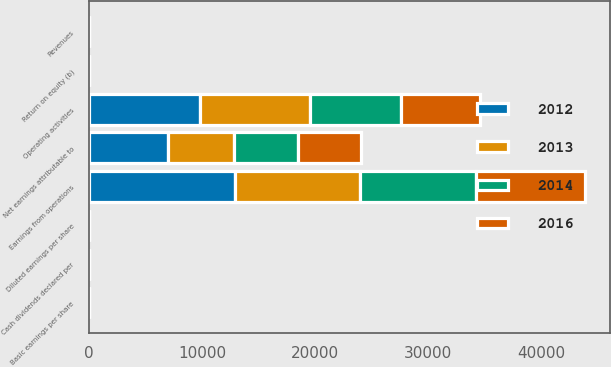<chart> <loc_0><loc_0><loc_500><loc_500><stacked_bar_chart><ecel><fcel>Revenues<fcel>Earnings from operations<fcel>Net earnings attributable to<fcel>Return on equity (b)<fcel>Basic earnings per share<fcel>Diluted earnings per share<fcel>Cash dividends declared per<fcel>Operating activities<nl><fcel>2012<fcel>17.7<fcel>12930<fcel>7017<fcel>19.4<fcel>7.37<fcel>7.25<fcel>2.38<fcel>9795<nl><fcel>2013<fcel>17.7<fcel>11021<fcel>5813<fcel>17.7<fcel>6.1<fcel>6.01<fcel>1.88<fcel>9740<nl><fcel>2014<fcel>17.7<fcel>10274<fcel>5619<fcel>17.3<fcel>5.78<fcel>5.7<fcel>1.41<fcel>8051<nl><fcel>2016<fcel>17.7<fcel>9623<fcel>5625<fcel>17.7<fcel>5.59<fcel>5.5<fcel>1.05<fcel>6991<nl></chart> 